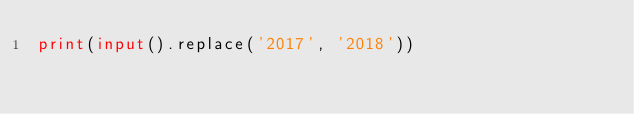<code> <loc_0><loc_0><loc_500><loc_500><_Python_>print(input().replace('2017', '2018'))</code> 